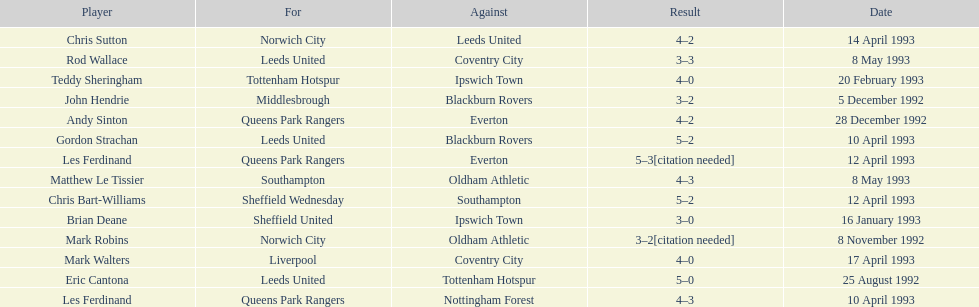Name the only player from france. Eric Cantona. 